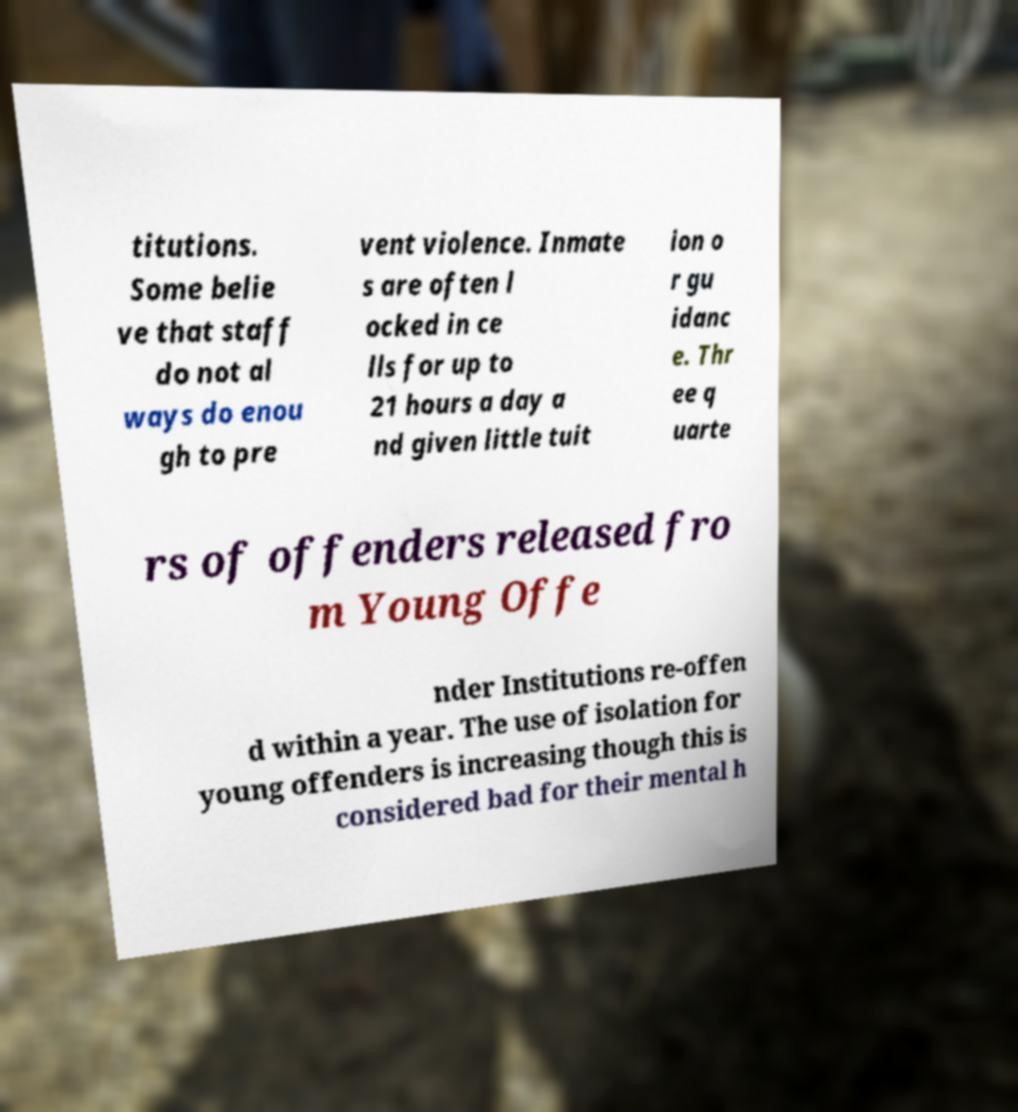Can you read and provide the text displayed in the image?This photo seems to have some interesting text. Can you extract and type it out for me? titutions. Some belie ve that staff do not al ways do enou gh to pre vent violence. Inmate s are often l ocked in ce lls for up to 21 hours a day a nd given little tuit ion o r gu idanc e. Thr ee q uarte rs of offenders released fro m Young Offe nder Institutions re-offen d within a year. The use of isolation for young offenders is increasing though this is considered bad for their mental h 